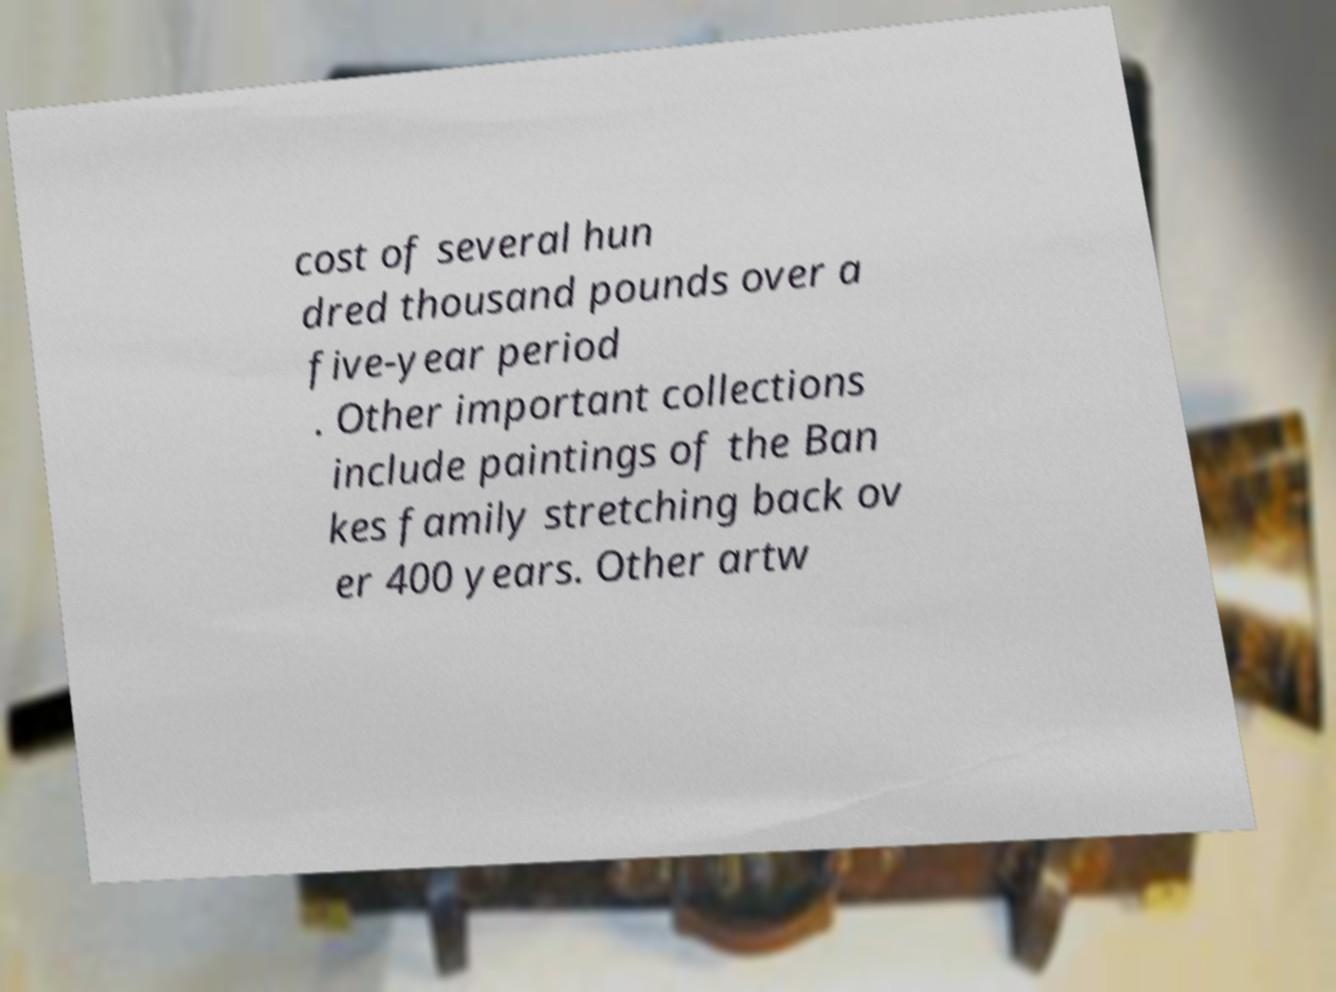There's text embedded in this image that I need extracted. Can you transcribe it verbatim? cost of several hun dred thousand pounds over a five-year period . Other important collections include paintings of the Ban kes family stretching back ov er 400 years. Other artw 